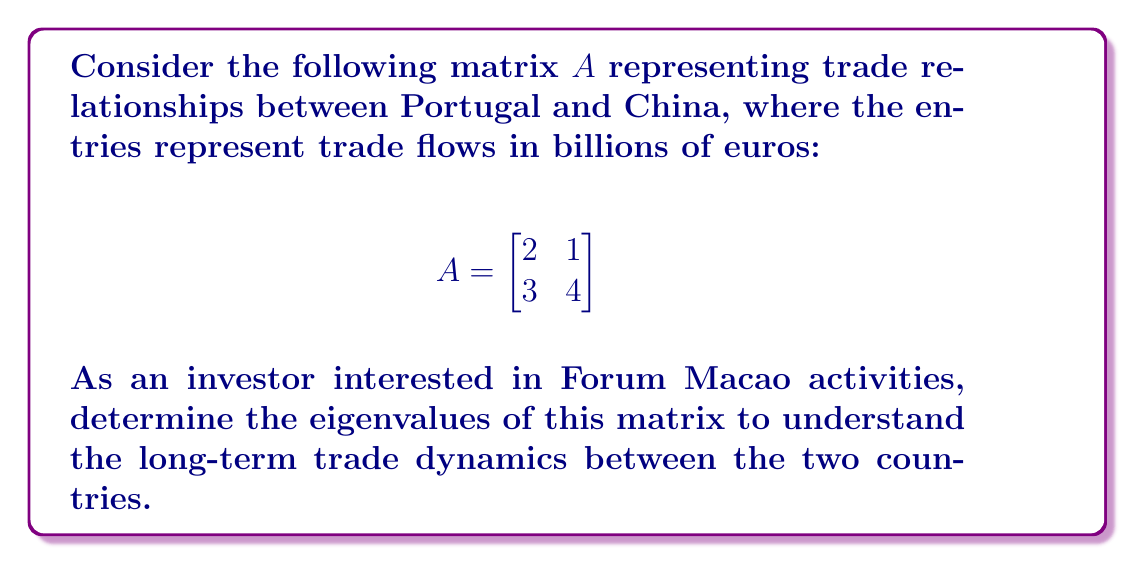Can you solve this math problem? To find the eigenvalues of matrix $A$, we follow these steps:

1) The characteristic equation is given by $det(A - \lambda I) = 0$, where $\lambda$ represents the eigenvalues and $I$ is the 2x2 identity matrix.

2) Expand the determinant:

   $$det\begin{bmatrix}
   2-\lambda & 1 \\
   3 & 4-\lambda
   \end{bmatrix} = 0$$

3) Calculate the determinant:
   
   $(2-\lambda)(4-\lambda) - 3 \cdot 1 = 0$

4) Expand the equation:
   
   $8 - 2\lambda - 4\lambda + \lambda^2 - 3 = 0$
   
   $\lambda^2 - 6\lambda + 5 = 0$

5) This is a quadratic equation. We can solve it using the quadratic formula:
   
   $\lambda = \frac{-b \pm \sqrt{b^2 - 4ac}}{2a}$

   Where $a=1$, $b=-6$, and $c=5$

6) Plugging in the values:

   $\lambda = \frac{6 \pm \sqrt{36 - 20}}{2} = \frac{6 \pm \sqrt{16}}{2} = \frac{6 \pm 4}{2}$

7) Therefore, the eigenvalues are:

   $\lambda_1 = \frac{6 + 4}{2} = 5$ and $\lambda_2 = \frac{6 - 4}{2} = 1$

These eigenvalues indicate the long-term growth rates of trade between Portugal and China under this model.
Answer: $\lambda_1 = 5$, $\lambda_2 = 1$ 